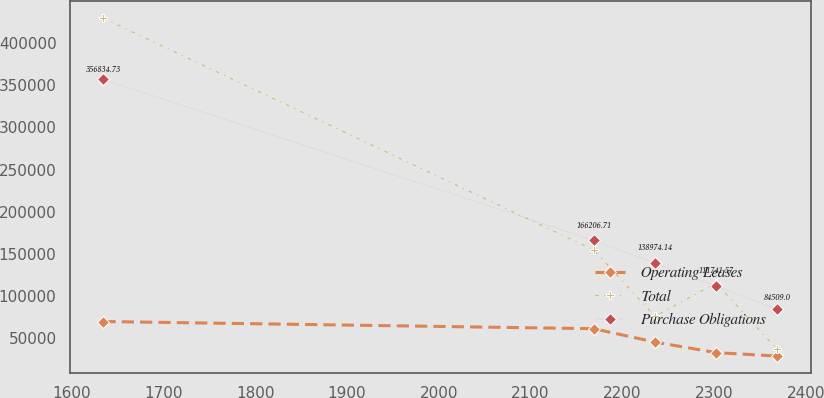Convert chart. <chart><loc_0><loc_0><loc_500><loc_500><line_chart><ecel><fcel>Operating Leases<fcel>Total<fcel>Purchase Obligations<nl><fcel>1634.78<fcel>69952.7<fcel>429475<fcel>356835<nl><fcel>2168.74<fcel>61432<fcel>154699<fcel>166207<nl><fcel>2235.36<fcel>45610.7<fcel>76191.9<fcel>138974<nl><fcel>2301.98<fcel>33084.8<fcel>115446<fcel>111742<nl><fcel>2368.6<fcel>28988.4<fcel>36938.2<fcel>84509<nl></chart> 